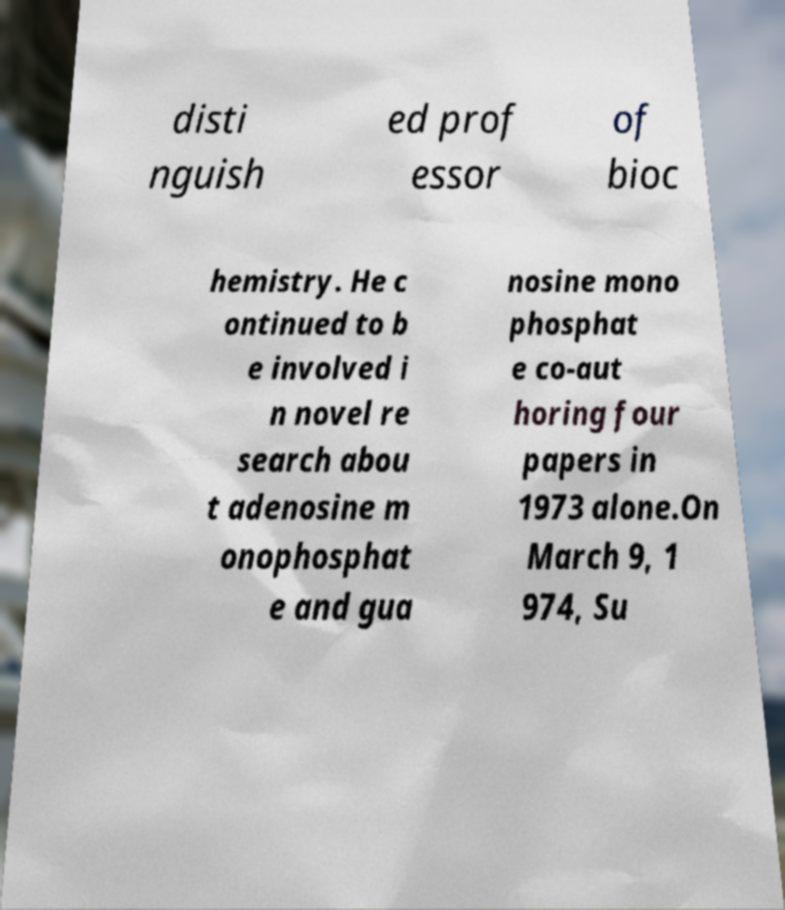Please read and relay the text visible in this image. What does it say? disti nguish ed prof essor of bioc hemistry. He c ontinued to b e involved i n novel re search abou t adenosine m onophosphat e and gua nosine mono phosphat e co-aut horing four papers in 1973 alone.On March 9, 1 974, Su 